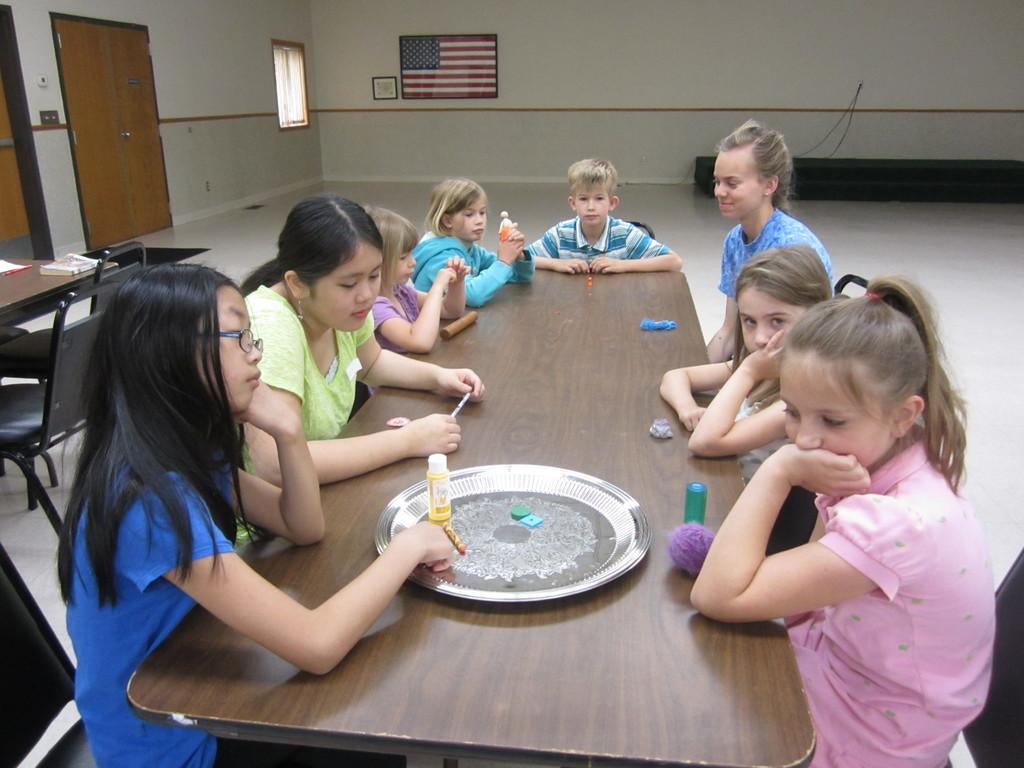What is the main subject of the image? The main subject of the image is a group of children. Where are the children located in the image? The children are sitting in front of a table. What is on the table in the image? There is a plate on the table. What type of observation is the farmer making about the beast in the image? There is no farmer or beast present in the image; it features a group of children sitting in front of a table. 